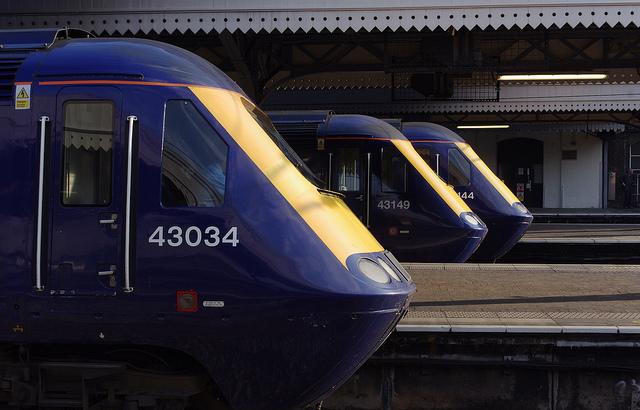What surface allows the trains to be mobile? tracks 